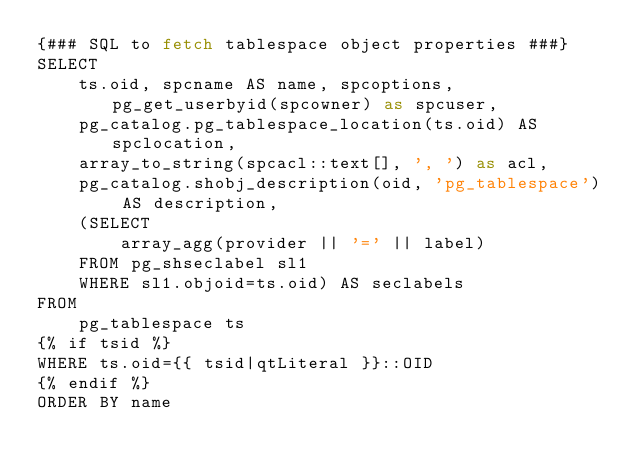<code> <loc_0><loc_0><loc_500><loc_500><_SQL_>{### SQL to fetch tablespace object properties ###}
SELECT
    ts.oid, spcname AS name, spcoptions, pg_get_userbyid(spcowner) as spcuser,
    pg_catalog.pg_tablespace_location(ts.oid) AS spclocation,
    array_to_string(spcacl::text[], ', ') as acl,
    pg_catalog.shobj_description(oid, 'pg_tablespace') AS description,
    (SELECT
        array_agg(provider || '=' || label)
    FROM pg_shseclabel sl1
    WHERE sl1.objoid=ts.oid) AS seclabels
FROM
    pg_tablespace ts
{% if tsid %}
WHERE ts.oid={{ tsid|qtLiteral }}::OID
{% endif %}
ORDER BY name
</code> 